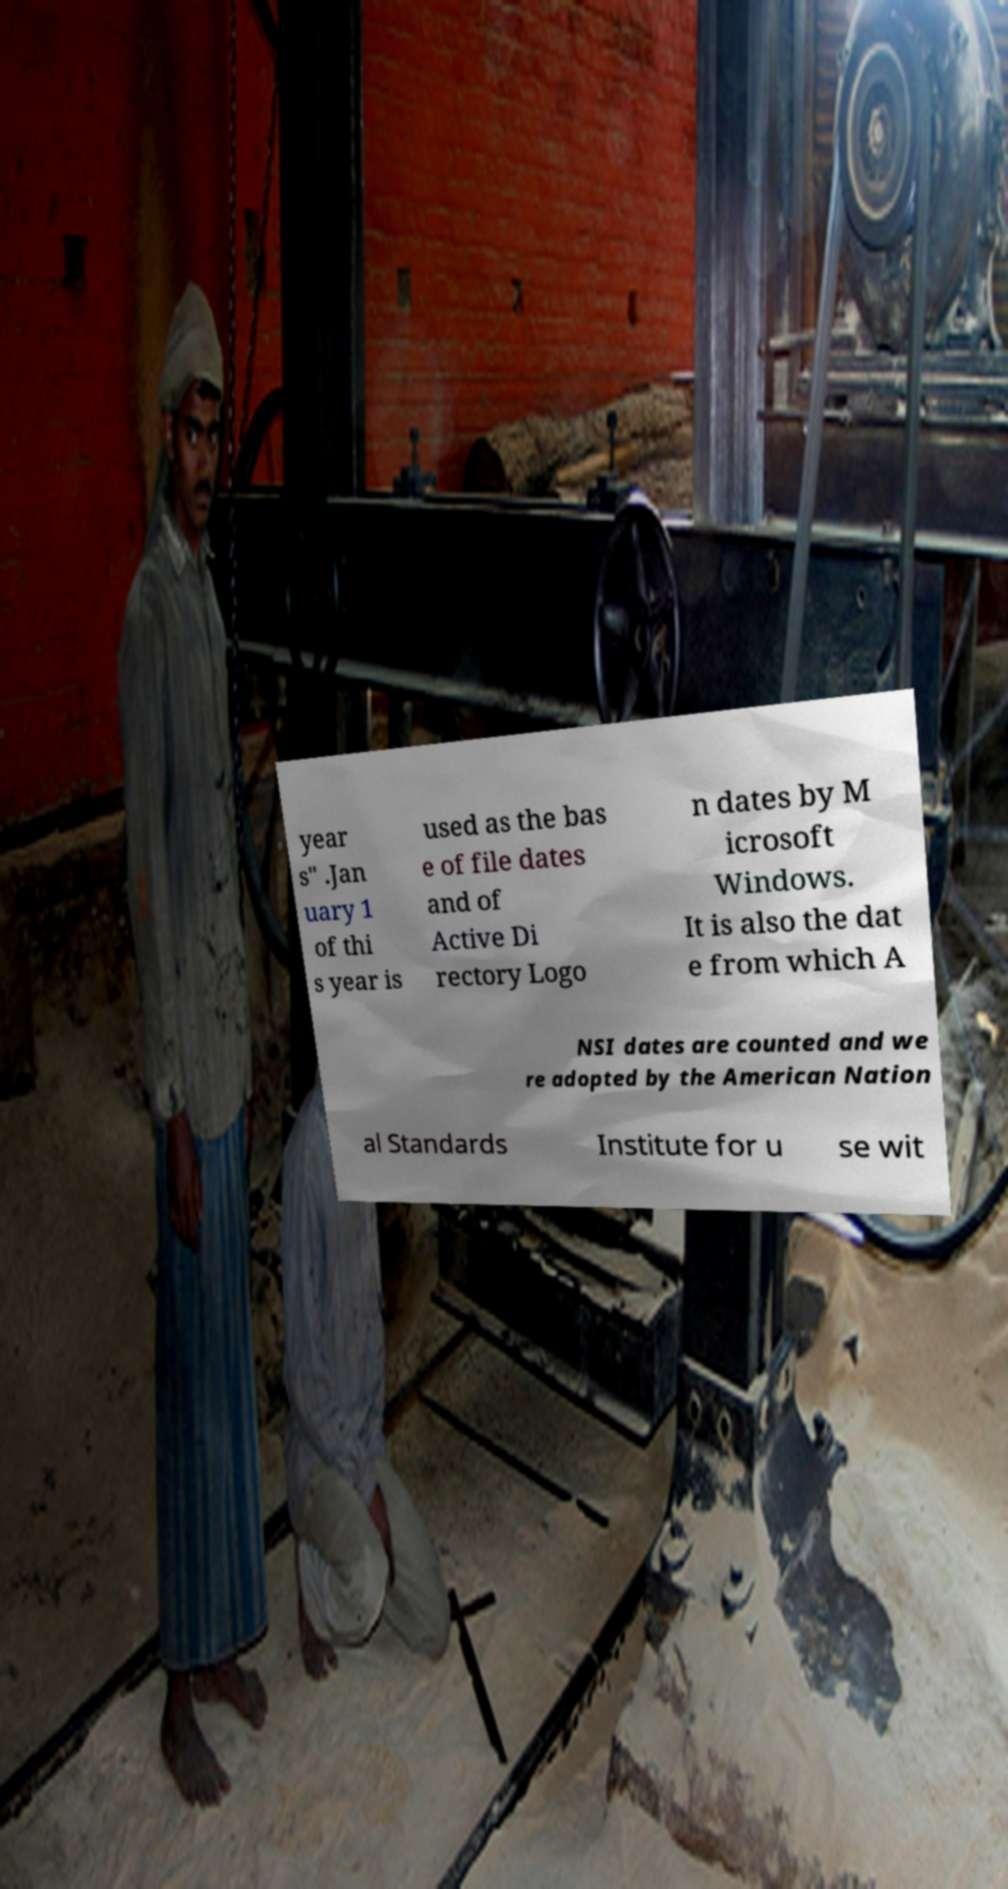Please read and relay the text visible in this image. What does it say? year s" .Jan uary 1 of thi s year is used as the bas e of file dates and of Active Di rectory Logo n dates by M icrosoft Windows. It is also the dat e from which A NSI dates are counted and we re adopted by the American Nation al Standards Institute for u se wit 